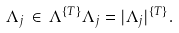<formula> <loc_0><loc_0><loc_500><loc_500>\Lambda _ { j } \, \in \, \Lambda ^ { \{ T \} } \Lambda _ { j } = | \Lambda _ { j } | ^ { \{ T \} } .</formula> 